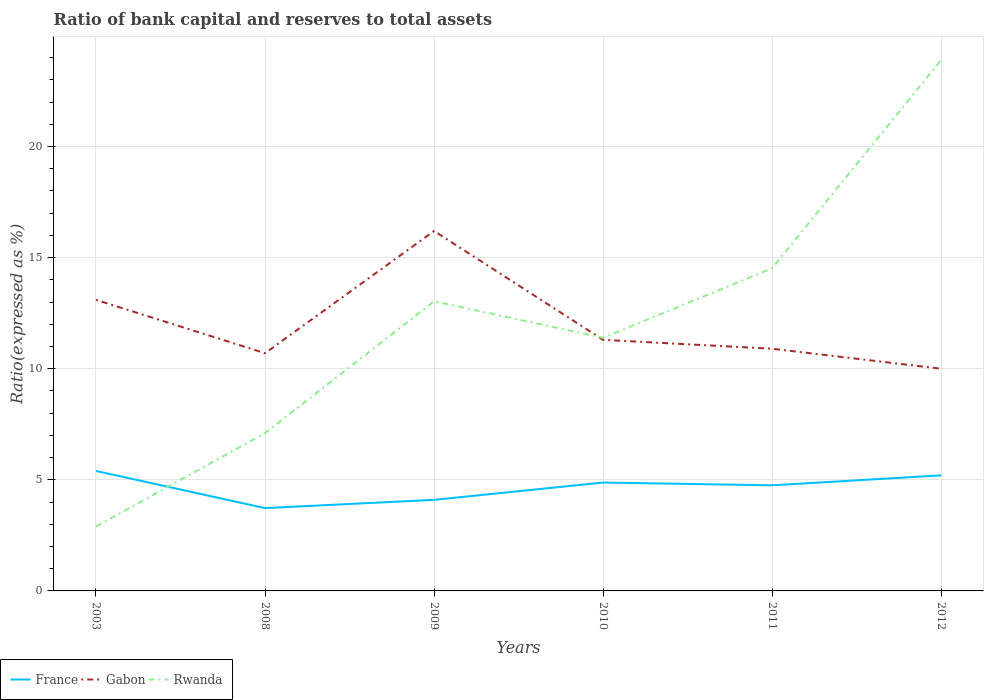How many different coloured lines are there?
Your answer should be very brief. 3. Does the line corresponding to France intersect with the line corresponding to Gabon?
Your answer should be compact. No. Is the number of lines equal to the number of legend labels?
Keep it short and to the point. Yes. Across all years, what is the maximum ratio of bank capital and reserves to total assets in Gabon?
Your answer should be compact. 10. What is the total ratio of bank capital and reserves to total assets in Rwanda in the graph?
Your answer should be compact. -3.13. What is the difference between the highest and the second highest ratio of bank capital and reserves to total assets in Gabon?
Offer a terse response. 6.2. What is the difference between the highest and the lowest ratio of bank capital and reserves to total assets in Rwanda?
Give a very brief answer. 3. What is the difference between two consecutive major ticks on the Y-axis?
Ensure brevity in your answer.  5. Does the graph contain any zero values?
Ensure brevity in your answer.  No. Does the graph contain grids?
Offer a very short reply. Yes. How many legend labels are there?
Keep it short and to the point. 3. How are the legend labels stacked?
Provide a short and direct response. Horizontal. What is the title of the graph?
Keep it short and to the point. Ratio of bank capital and reserves to total assets. Does "Benin" appear as one of the legend labels in the graph?
Offer a terse response. No. What is the label or title of the X-axis?
Your response must be concise. Years. What is the label or title of the Y-axis?
Your response must be concise. Ratio(expressed as %). What is the Ratio(expressed as %) of France in 2003?
Offer a terse response. 5.4. What is the Ratio(expressed as %) in Rwanda in 2003?
Your answer should be compact. 2.9. What is the Ratio(expressed as %) of France in 2008?
Give a very brief answer. 3.73. What is the Ratio(expressed as %) in Gabon in 2008?
Provide a succinct answer. 10.7. What is the Ratio(expressed as %) in France in 2009?
Offer a terse response. 4.1. What is the Ratio(expressed as %) in Gabon in 2009?
Ensure brevity in your answer.  16.2. What is the Ratio(expressed as %) of Rwanda in 2009?
Your answer should be very brief. 13.04. What is the Ratio(expressed as %) in France in 2010?
Make the answer very short. 4.88. What is the Ratio(expressed as %) of Rwanda in 2010?
Your response must be concise. 11.4. What is the Ratio(expressed as %) of France in 2011?
Give a very brief answer. 4.75. What is the Ratio(expressed as %) of Gabon in 2011?
Offer a terse response. 10.9. What is the Ratio(expressed as %) of Rwanda in 2011?
Your answer should be very brief. 14.53. What is the Ratio(expressed as %) of France in 2012?
Give a very brief answer. 5.2. What is the Ratio(expressed as %) in Rwanda in 2012?
Ensure brevity in your answer.  23.9. Across all years, what is the maximum Ratio(expressed as %) in France?
Your answer should be very brief. 5.4. Across all years, what is the maximum Ratio(expressed as %) in Gabon?
Keep it short and to the point. 16.2. Across all years, what is the maximum Ratio(expressed as %) of Rwanda?
Provide a succinct answer. 23.9. Across all years, what is the minimum Ratio(expressed as %) of France?
Keep it short and to the point. 3.73. What is the total Ratio(expressed as %) of France in the graph?
Offer a very short reply. 28.06. What is the total Ratio(expressed as %) in Gabon in the graph?
Make the answer very short. 72.2. What is the total Ratio(expressed as %) of Rwanda in the graph?
Provide a succinct answer. 72.86. What is the difference between the Ratio(expressed as %) in France in 2003 and that in 2008?
Give a very brief answer. 1.67. What is the difference between the Ratio(expressed as %) of Rwanda in 2003 and that in 2008?
Provide a succinct answer. -4.2. What is the difference between the Ratio(expressed as %) in France in 2003 and that in 2009?
Give a very brief answer. 1.3. What is the difference between the Ratio(expressed as %) in Rwanda in 2003 and that in 2009?
Offer a terse response. -10.14. What is the difference between the Ratio(expressed as %) of France in 2003 and that in 2010?
Offer a terse response. 0.52. What is the difference between the Ratio(expressed as %) of Gabon in 2003 and that in 2010?
Make the answer very short. 1.8. What is the difference between the Ratio(expressed as %) of Rwanda in 2003 and that in 2010?
Give a very brief answer. -8.5. What is the difference between the Ratio(expressed as %) in France in 2003 and that in 2011?
Give a very brief answer. 0.65. What is the difference between the Ratio(expressed as %) of Rwanda in 2003 and that in 2011?
Offer a very short reply. -11.63. What is the difference between the Ratio(expressed as %) of France in 2003 and that in 2012?
Ensure brevity in your answer.  0.2. What is the difference between the Ratio(expressed as %) of Gabon in 2003 and that in 2012?
Offer a terse response. 3.1. What is the difference between the Ratio(expressed as %) in France in 2008 and that in 2009?
Give a very brief answer. -0.37. What is the difference between the Ratio(expressed as %) of Gabon in 2008 and that in 2009?
Give a very brief answer. -5.5. What is the difference between the Ratio(expressed as %) in Rwanda in 2008 and that in 2009?
Provide a short and direct response. -5.94. What is the difference between the Ratio(expressed as %) in France in 2008 and that in 2010?
Give a very brief answer. -1.15. What is the difference between the Ratio(expressed as %) of Gabon in 2008 and that in 2010?
Keep it short and to the point. -0.6. What is the difference between the Ratio(expressed as %) in Rwanda in 2008 and that in 2010?
Provide a succinct answer. -4.3. What is the difference between the Ratio(expressed as %) in France in 2008 and that in 2011?
Keep it short and to the point. -1.03. What is the difference between the Ratio(expressed as %) of Rwanda in 2008 and that in 2011?
Provide a succinct answer. -7.43. What is the difference between the Ratio(expressed as %) in France in 2008 and that in 2012?
Provide a succinct answer. -1.47. What is the difference between the Ratio(expressed as %) in Rwanda in 2008 and that in 2012?
Your answer should be very brief. -16.8. What is the difference between the Ratio(expressed as %) of France in 2009 and that in 2010?
Provide a short and direct response. -0.78. What is the difference between the Ratio(expressed as %) in Gabon in 2009 and that in 2010?
Make the answer very short. 4.9. What is the difference between the Ratio(expressed as %) in Rwanda in 2009 and that in 2010?
Your answer should be very brief. 1.64. What is the difference between the Ratio(expressed as %) in France in 2009 and that in 2011?
Make the answer very short. -0.66. What is the difference between the Ratio(expressed as %) in Gabon in 2009 and that in 2011?
Offer a very short reply. 5.3. What is the difference between the Ratio(expressed as %) in Rwanda in 2009 and that in 2011?
Your answer should be very brief. -1.49. What is the difference between the Ratio(expressed as %) in France in 2009 and that in 2012?
Keep it short and to the point. -1.1. What is the difference between the Ratio(expressed as %) in Gabon in 2009 and that in 2012?
Provide a short and direct response. 6.2. What is the difference between the Ratio(expressed as %) in Rwanda in 2009 and that in 2012?
Make the answer very short. -10.86. What is the difference between the Ratio(expressed as %) of France in 2010 and that in 2011?
Your answer should be compact. 0.12. What is the difference between the Ratio(expressed as %) of Gabon in 2010 and that in 2011?
Your answer should be compact. 0.4. What is the difference between the Ratio(expressed as %) in Rwanda in 2010 and that in 2011?
Offer a very short reply. -3.13. What is the difference between the Ratio(expressed as %) of France in 2010 and that in 2012?
Your answer should be very brief. -0.32. What is the difference between the Ratio(expressed as %) of Gabon in 2010 and that in 2012?
Make the answer very short. 1.3. What is the difference between the Ratio(expressed as %) of Rwanda in 2010 and that in 2012?
Provide a succinct answer. -12.5. What is the difference between the Ratio(expressed as %) of France in 2011 and that in 2012?
Provide a succinct answer. -0.45. What is the difference between the Ratio(expressed as %) in Rwanda in 2011 and that in 2012?
Offer a terse response. -9.37. What is the difference between the Ratio(expressed as %) of France in 2003 and the Ratio(expressed as %) of Gabon in 2008?
Your answer should be compact. -5.3. What is the difference between the Ratio(expressed as %) of France in 2003 and the Ratio(expressed as %) of Rwanda in 2008?
Provide a succinct answer. -1.7. What is the difference between the Ratio(expressed as %) in Gabon in 2003 and the Ratio(expressed as %) in Rwanda in 2008?
Offer a very short reply. 6. What is the difference between the Ratio(expressed as %) of France in 2003 and the Ratio(expressed as %) of Rwanda in 2009?
Offer a terse response. -7.64. What is the difference between the Ratio(expressed as %) in Gabon in 2003 and the Ratio(expressed as %) in Rwanda in 2009?
Offer a terse response. 0.06. What is the difference between the Ratio(expressed as %) in France in 2003 and the Ratio(expressed as %) in Gabon in 2010?
Make the answer very short. -5.9. What is the difference between the Ratio(expressed as %) in France in 2003 and the Ratio(expressed as %) in Rwanda in 2010?
Offer a terse response. -6. What is the difference between the Ratio(expressed as %) in Gabon in 2003 and the Ratio(expressed as %) in Rwanda in 2010?
Provide a short and direct response. 1.7. What is the difference between the Ratio(expressed as %) in France in 2003 and the Ratio(expressed as %) in Gabon in 2011?
Provide a short and direct response. -5.5. What is the difference between the Ratio(expressed as %) in France in 2003 and the Ratio(expressed as %) in Rwanda in 2011?
Ensure brevity in your answer.  -9.13. What is the difference between the Ratio(expressed as %) in Gabon in 2003 and the Ratio(expressed as %) in Rwanda in 2011?
Your answer should be compact. -1.43. What is the difference between the Ratio(expressed as %) in France in 2003 and the Ratio(expressed as %) in Rwanda in 2012?
Your answer should be compact. -18.5. What is the difference between the Ratio(expressed as %) of Gabon in 2003 and the Ratio(expressed as %) of Rwanda in 2012?
Keep it short and to the point. -10.8. What is the difference between the Ratio(expressed as %) in France in 2008 and the Ratio(expressed as %) in Gabon in 2009?
Give a very brief answer. -12.47. What is the difference between the Ratio(expressed as %) in France in 2008 and the Ratio(expressed as %) in Rwanda in 2009?
Your answer should be very brief. -9.31. What is the difference between the Ratio(expressed as %) in Gabon in 2008 and the Ratio(expressed as %) in Rwanda in 2009?
Provide a succinct answer. -2.34. What is the difference between the Ratio(expressed as %) of France in 2008 and the Ratio(expressed as %) of Gabon in 2010?
Your response must be concise. -7.57. What is the difference between the Ratio(expressed as %) in France in 2008 and the Ratio(expressed as %) in Rwanda in 2010?
Provide a short and direct response. -7.67. What is the difference between the Ratio(expressed as %) in Gabon in 2008 and the Ratio(expressed as %) in Rwanda in 2010?
Offer a terse response. -0.7. What is the difference between the Ratio(expressed as %) of France in 2008 and the Ratio(expressed as %) of Gabon in 2011?
Keep it short and to the point. -7.17. What is the difference between the Ratio(expressed as %) in France in 2008 and the Ratio(expressed as %) in Rwanda in 2011?
Your answer should be very brief. -10.8. What is the difference between the Ratio(expressed as %) of Gabon in 2008 and the Ratio(expressed as %) of Rwanda in 2011?
Offer a very short reply. -3.83. What is the difference between the Ratio(expressed as %) of France in 2008 and the Ratio(expressed as %) of Gabon in 2012?
Offer a terse response. -6.27. What is the difference between the Ratio(expressed as %) of France in 2008 and the Ratio(expressed as %) of Rwanda in 2012?
Offer a very short reply. -20.17. What is the difference between the Ratio(expressed as %) of Gabon in 2008 and the Ratio(expressed as %) of Rwanda in 2012?
Give a very brief answer. -13.2. What is the difference between the Ratio(expressed as %) of France in 2009 and the Ratio(expressed as %) of Gabon in 2010?
Ensure brevity in your answer.  -7.2. What is the difference between the Ratio(expressed as %) of France in 2009 and the Ratio(expressed as %) of Rwanda in 2010?
Make the answer very short. -7.3. What is the difference between the Ratio(expressed as %) in Gabon in 2009 and the Ratio(expressed as %) in Rwanda in 2010?
Offer a terse response. 4.8. What is the difference between the Ratio(expressed as %) of France in 2009 and the Ratio(expressed as %) of Gabon in 2011?
Make the answer very short. -6.8. What is the difference between the Ratio(expressed as %) in France in 2009 and the Ratio(expressed as %) in Rwanda in 2011?
Make the answer very short. -10.43. What is the difference between the Ratio(expressed as %) in Gabon in 2009 and the Ratio(expressed as %) in Rwanda in 2011?
Make the answer very short. 1.67. What is the difference between the Ratio(expressed as %) in France in 2009 and the Ratio(expressed as %) in Gabon in 2012?
Offer a terse response. -5.9. What is the difference between the Ratio(expressed as %) in France in 2009 and the Ratio(expressed as %) in Rwanda in 2012?
Keep it short and to the point. -19.8. What is the difference between the Ratio(expressed as %) in Gabon in 2009 and the Ratio(expressed as %) in Rwanda in 2012?
Your answer should be very brief. -7.7. What is the difference between the Ratio(expressed as %) in France in 2010 and the Ratio(expressed as %) in Gabon in 2011?
Keep it short and to the point. -6.02. What is the difference between the Ratio(expressed as %) in France in 2010 and the Ratio(expressed as %) in Rwanda in 2011?
Your answer should be very brief. -9.65. What is the difference between the Ratio(expressed as %) in Gabon in 2010 and the Ratio(expressed as %) in Rwanda in 2011?
Provide a short and direct response. -3.23. What is the difference between the Ratio(expressed as %) in France in 2010 and the Ratio(expressed as %) in Gabon in 2012?
Give a very brief answer. -5.12. What is the difference between the Ratio(expressed as %) in France in 2010 and the Ratio(expressed as %) in Rwanda in 2012?
Keep it short and to the point. -19.02. What is the difference between the Ratio(expressed as %) of France in 2011 and the Ratio(expressed as %) of Gabon in 2012?
Ensure brevity in your answer.  -5.25. What is the difference between the Ratio(expressed as %) in France in 2011 and the Ratio(expressed as %) in Rwanda in 2012?
Keep it short and to the point. -19.15. What is the difference between the Ratio(expressed as %) in Gabon in 2011 and the Ratio(expressed as %) in Rwanda in 2012?
Your answer should be compact. -13. What is the average Ratio(expressed as %) in France per year?
Your response must be concise. 4.68. What is the average Ratio(expressed as %) of Gabon per year?
Offer a very short reply. 12.03. What is the average Ratio(expressed as %) in Rwanda per year?
Offer a very short reply. 12.14. In the year 2003, what is the difference between the Ratio(expressed as %) of France and Ratio(expressed as %) of Gabon?
Offer a very short reply. -7.7. In the year 2003, what is the difference between the Ratio(expressed as %) in Gabon and Ratio(expressed as %) in Rwanda?
Your answer should be compact. 10.2. In the year 2008, what is the difference between the Ratio(expressed as %) in France and Ratio(expressed as %) in Gabon?
Keep it short and to the point. -6.97. In the year 2008, what is the difference between the Ratio(expressed as %) in France and Ratio(expressed as %) in Rwanda?
Make the answer very short. -3.37. In the year 2008, what is the difference between the Ratio(expressed as %) of Gabon and Ratio(expressed as %) of Rwanda?
Give a very brief answer. 3.6. In the year 2009, what is the difference between the Ratio(expressed as %) of France and Ratio(expressed as %) of Gabon?
Provide a succinct answer. -12.1. In the year 2009, what is the difference between the Ratio(expressed as %) in France and Ratio(expressed as %) in Rwanda?
Keep it short and to the point. -8.94. In the year 2009, what is the difference between the Ratio(expressed as %) in Gabon and Ratio(expressed as %) in Rwanda?
Your answer should be very brief. 3.16. In the year 2010, what is the difference between the Ratio(expressed as %) of France and Ratio(expressed as %) of Gabon?
Your answer should be compact. -6.42. In the year 2010, what is the difference between the Ratio(expressed as %) of France and Ratio(expressed as %) of Rwanda?
Ensure brevity in your answer.  -6.52. In the year 2010, what is the difference between the Ratio(expressed as %) in Gabon and Ratio(expressed as %) in Rwanda?
Offer a very short reply. -0.1. In the year 2011, what is the difference between the Ratio(expressed as %) of France and Ratio(expressed as %) of Gabon?
Provide a succinct answer. -6.15. In the year 2011, what is the difference between the Ratio(expressed as %) in France and Ratio(expressed as %) in Rwanda?
Your answer should be very brief. -9.77. In the year 2011, what is the difference between the Ratio(expressed as %) in Gabon and Ratio(expressed as %) in Rwanda?
Offer a very short reply. -3.63. In the year 2012, what is the difference between the Ratio(expressed as %) of France and Ratio(expressed as %) of Gabon?
Provide a short and direct response. -4.8. In the year 2012, what is the difference between the Ratio(expressed as %) of France and Ratio(expressed as %) of Rwanda?
Provide a short and direct response. -18.7. What is the ratio of the Ratio(expressed as %) in France in 2003 to that in 2008?
Your answer should be compact. 1.45. What is the ratio of the Ratio(expressed as %) in Gabon in 2003 to that in 2008?
Your answer should be very brief. 1.22. What is the ratio of the Ratio(expressed as %) of Rwanda in 2003 to that in 2008?
Keep it short and to the point. 0.41. What is the ratio of the Ratio(expressed as %) of France in 2003 to that in 2009?
Your answer should be compact. 1.32. What is the ratio of the Ratio(expressed as %) in Gabon in 2003 to that in 2009?
Your answer should be compact. 0.81. What is the ratio of the Ratio(expressed as %) in Rwanda in 2003 to that in 2009?
Your response must be concise. 0.22. What is the ratio of the Ratio(expressed as %) of France in 2003 to that in 2010?
Offer a terse response. 1.11. What is the ratio of the Ratio(expressed as %) in Gabon in 2003 to that in 2010?
Give a very brief answer. 1.16. What is the ratio of the Ratio(expressed as %) in Rwanda in 2003 to that in 2010?
Offer a terse response. 0.25. What is the ratio of the Ratio(expressed as %) of France in 2003 to that in 2011?
Provide a short and direct response. 1.14. What is the ratio of the Ratio(expressed as %) of Gabon in 2003 to that in 2011?
Keep it short and to the point. 1.2. What is the ratio of the Ratio(expressed as %) in Rwanda in 2003 to that in 2011?
Provide a succinct answer. 0.2. What is the ratio of the Ratio(expressed as %) of France in 2003 to that in 2012?
Provide a short and direct response. 1.04. What is the ratio of the Ratio(expressed as %) of Gabon in 2003 to that in 2012?
Your answer should be compact. 1.31. What is the ratio of the Ratio(expressed as %) of Rwanda in 2003 to that in 2012?
Make the answer very short. 0.12. What is the ratio of the Ratio(expressed as %) in France in 2008 to that in 2009?
Your response must be concise. 0.91. What is the ratio of the Ratio(expressed as %) of Gabon in 2008 to that in 2009?
Your response must be concise. 0.66. What is the ratio of the Ratio(expressed as %) in Rwanda in 2008 to that in 2009?
Ensure brevity in your answer.  0.54. What is the ratio of the Ratio(expressed as %) in France in 2008 to that in 2010?
Make the answer very short. 0.76. What is the ratio of the Ratio(expressed as %) in Gabon in 2008 to that in 2010?
Give a very brief answer. 0.95. What is the ratio of the Ratio(expressed as %) in Rwanda in 2008 to that in 2010?
Offer a terse response. 0.62. What is the ratio of the Ratio(expressed as %) in France in 2008 to that in 2011?
Your answer should be compact. 0.78. What is the ratio of the Ratio(expressed as %) in Gabon in 2008 to that in 2011?
Your response must be concise. 0.98. What is the ratio of the Ratio(expressed as %) in Rwanda in 2008 to that in 2011?
Offer a very short reply. 0.49. What is the ratio of the Ratio(expressed as %) of France in 2008 to that in 2012?
Keep it short and to the point. 0.72. What is the ratio of the Ratio(expressed as %) in Gabon in 2008 to that in 2012?
Ensure brevity in your answer.  1.07. What is the ratio of the Ratio(expressed as %) of Rwanda in 2008 to that in 2012?
Your response must be concise. 0.3. What is the ratio of the Ratio(expressed as %) in France in 2009 to that in 2010?
Make the answer very short. 0.84. What is the ratio of the Ratio(expressed as %) of Gabon in 2009 to that in 2010?
Give a very brief answer. 1.43. What is the ratio of the Ratio(expressed as %) in Rwanda in 2009 to that in 2010?
Offer a terse response. 1.14. What is the ratio of the Ratio(expressed as %) in France in 2009 to that in 2011?
Keep it short and to the point. 0.86. What is the ratio of the Ratio(expressed as %) of Gabon in 2009 to that in 2011?
Provide a succinct answer. 1.49. What is the ratio of the Ratio(expressed as %) of Rwanda in 2009 to that in 2011?
Offer a very short reply. 0.9. What is the ratio of the Ratio(expressed as %) of France in 2009 to that in 2012?
Give a very brief answer. 0.79. What is the ratio of the Ratio(expressed as %) in Gabon in 2009 to that in 2012?
Provide a short and direct response. 1.62. What is the ratio of the Ratio(expressed as %) of Rwanda in 2009 to that in 2012?
Make the answer very short. 0.55. What is the ratio of the Ratio(expressed as %) of France in 2010 to that in 2011?
Offer a terse response. 1.03. What is the ratio of the Ratio(expressed as %) in Gabon in 2010 to that in 2011?
Your answer should be compact. 1.04. What is the ratio of the Ratio(expressed as %) of Rwanda in 2010 to that in 2011?
Your response must be concise. 0.78. What is the ratio of the Ratio(expressed as %) in France in 2010 to that in 2012?
Keep it short and to the point. 0.94. What is the ratio of the Ratio(expressed as %) in Gabon in 2010 to that in 2012?
Make the answer very short. 1.13. What is the ratio of the Ratio(expressed as %) of Rwanda in 2010 to that in 2012?
Keep it short and to the point. 0.48. What is the ratio of the Ratio(expressed as %) of France in 2011 to that in 2012?
Offer a terse response. 0.91. What is the ratio of the Ratio(expressed as %) in Gabon in 2011 to that in 2012?
Your answer should be very brief. 1.09. What is the ratio of the Ratio(expressed as %) in Rwanda in 2011 to that in 2012?
Your answer should be very brief. 0.61. What is the difference between the highest and the second highest Ratio(expressed as %) in France?
Provide a succinct answer. 0.2. What is the difference between the highest and the second highest Ratio(expressed as %) of Gabon?
Your response must be concise. 3.1. What is the difference between the highest and the second highest Ratio(expressed as %) in Rwanda?
Your answer should be compact. 9.37. What is the difference between the highest and the lowest Ratio(expressed as %) in France?
Your response must be concise. 1.67. 